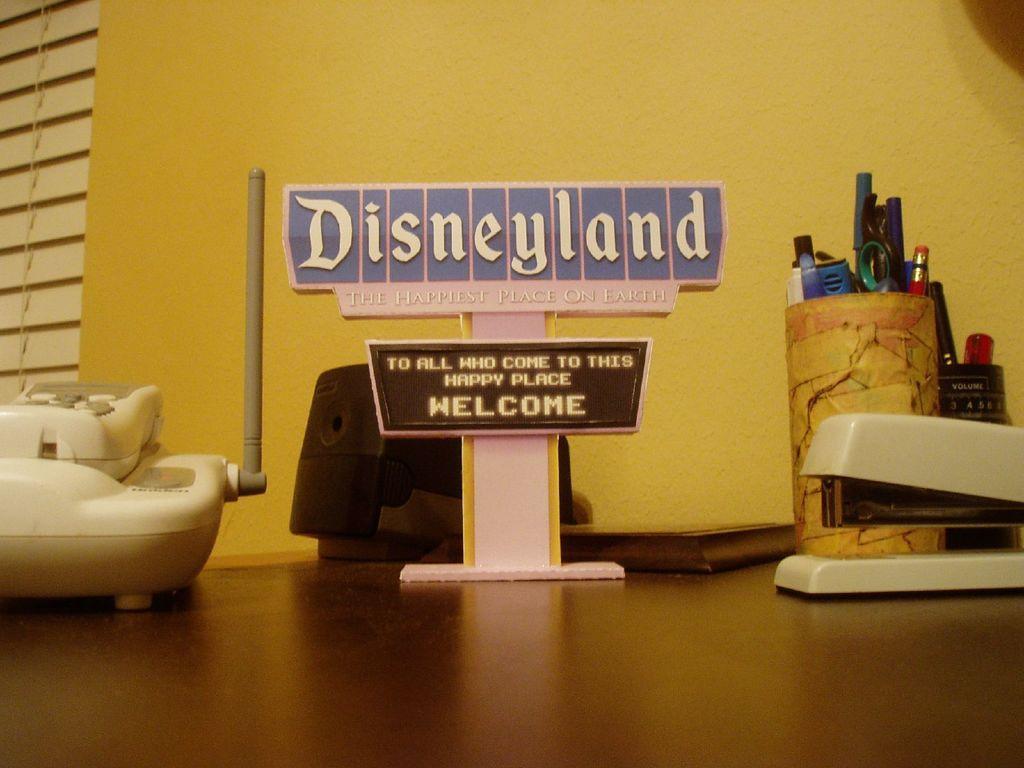Describe this image in one or two sentences. In this image I can see a telephone, a name board with stand and some other objects on the table. And in the background there is a wall. 